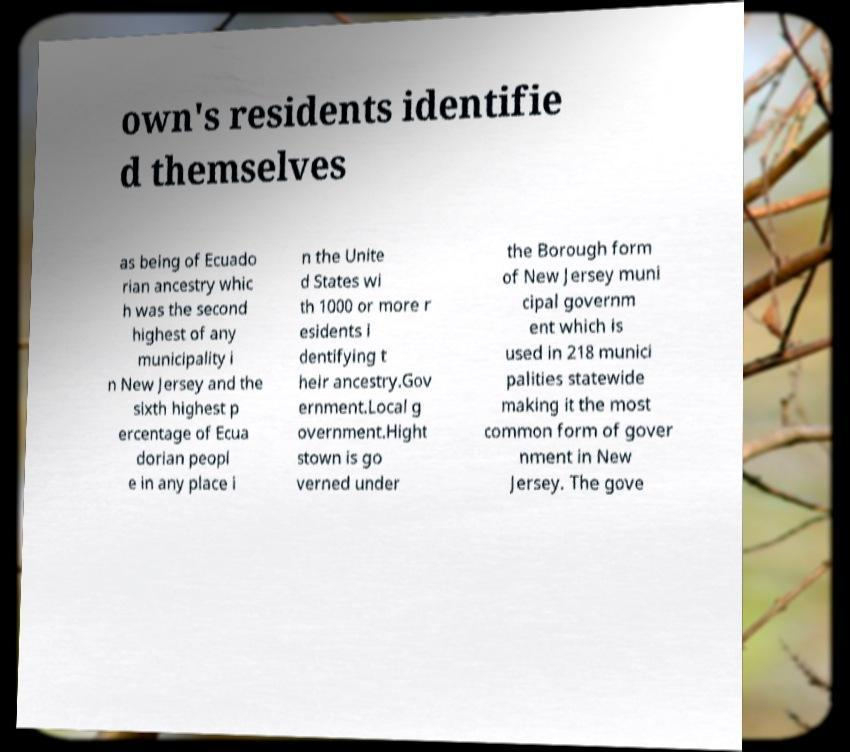I need the written content from this picture converted into text. Can you do that? own's residents identifie d themselves as being of Ecuado rian ancestry whic h was the second highest of any municipality i n New Jersey and the sixth highest p ercentage of Ecua dorian peopl e in any place i n the Unite d States wi th 1000 or more r esidents i dentifying t heir ancestry.Gov ernment.Local g overnment.Hight stown is go verned under the Borough form of New Jersey muni cipal governm ent which is used in 218 munici palities statewide making it the most common form of gover nment in New Jersey. The gove 